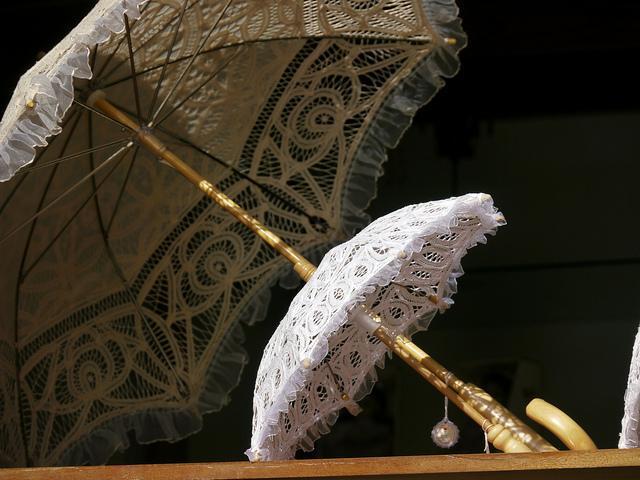How many umbrellas are there?
Give a very brief answer. 2. 